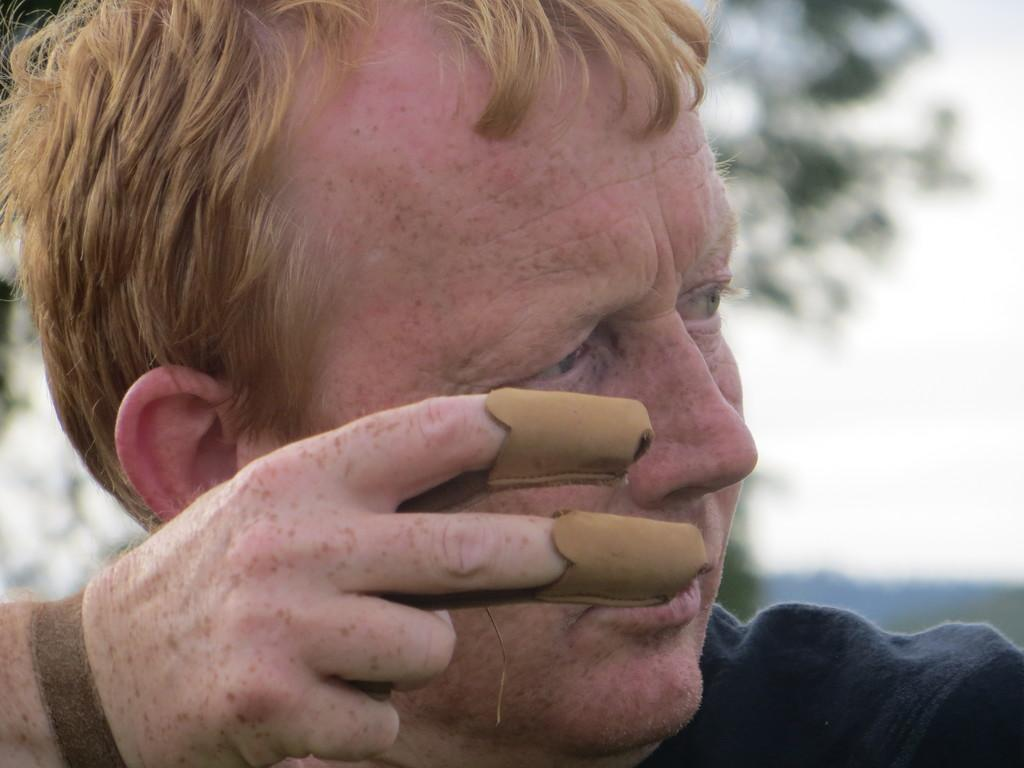What is present in the image? There is a person in the image. What is the person doing in the image? The person is holding an object. Can you describe the background of the image? The background of the image is blurred. How many cattle can be seen grazing in the background of the image? There are no cattle present in the image; the background is blurred. What type of button is the person wearing on their shirt in the image? There is no button visible on the person's shirt in the image. 